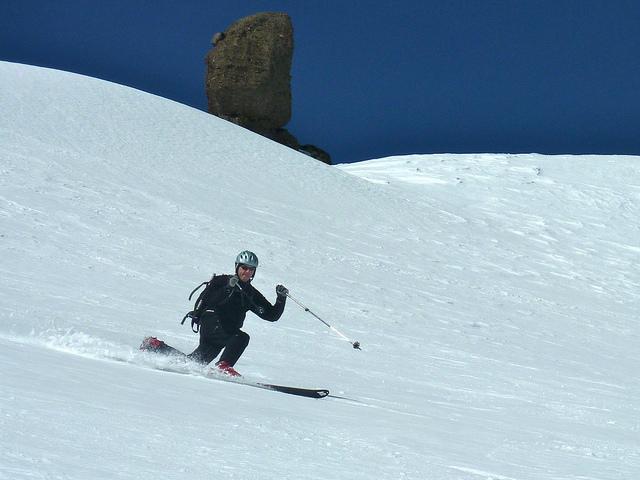Why is the man wearing the silver helmet?
Select the accurate answer and provide justification: `Answer: choice
Rationale: srationale.`
Options: For halloween, safety, for amusement, style. Answer: safety.
Rationale: The man is engaged in a physically dangerous activity, downhill skiing. wearing safety equipment is a prudent measure when engaged in dangerous activity. 